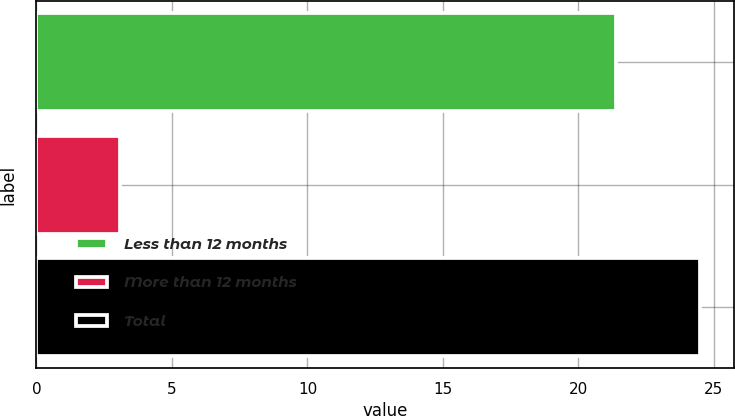Convert chart to OTSL. <chart><loc_0><loc_0><loc_500><loc_500><bar_chart><fcel>Less than 12 months<fcel>More than 12 months<fcel>Total<nl><fcel>21.4<fcel>3.1<fcel>24.5<nl></chart> 